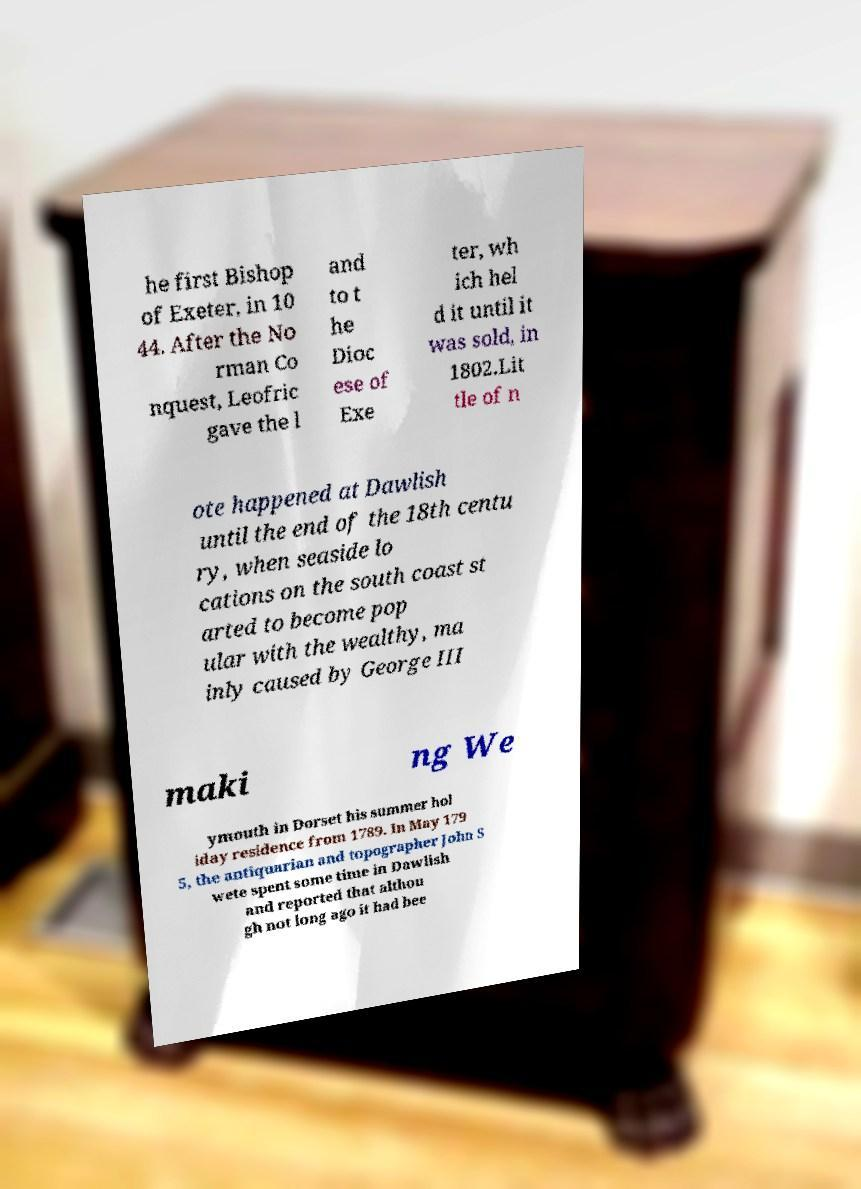Could you extract and type out the text from this image? he first Bishop of Exeter, in 10 44. After the No rman Co nquest, Leofric gave the l and to t he Dioc ese of Exe ter, wh ich hel d it until it was sold, in 1802.Lit tle of n ote happened at Dawlish until the end of the 18th centu ry, when seaside lo cations on the south coast st arted to become pop ular with the wealthy, ma inly caused by George III maki ng We ymouth in Dorset his summer hol iday residence from 1789. In May 179 5, the antiquarian and topographer John S wete spent some time in Dawlish and reported that althou gh not long ago it had bee 